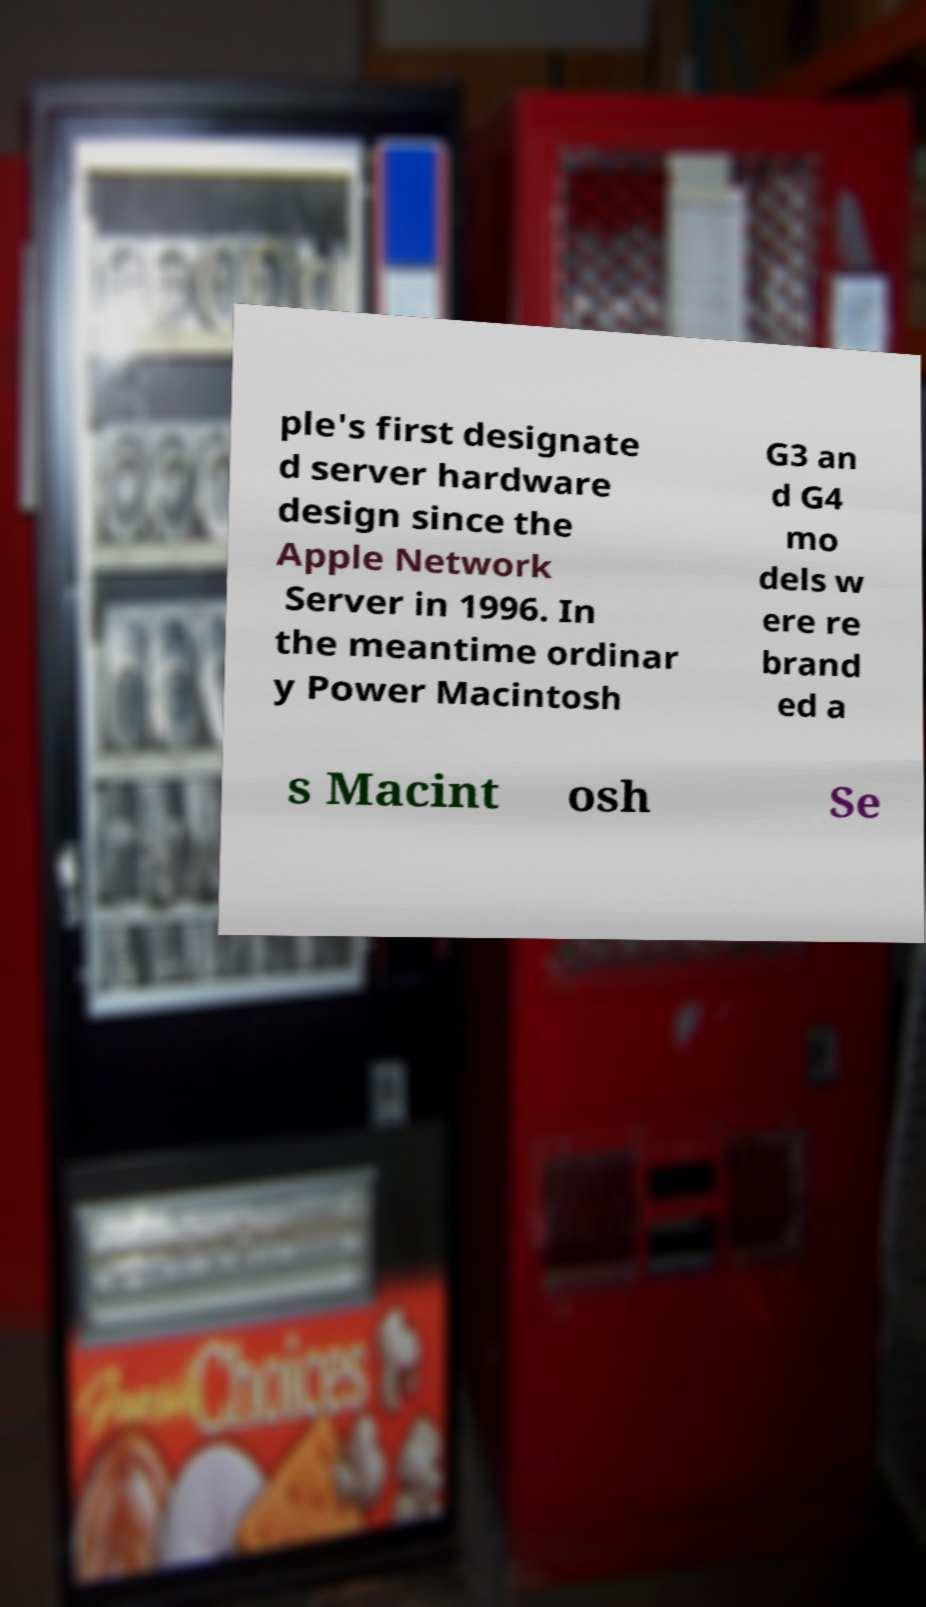Please read and relay the text visible in this image. What does it say? ple's first designate d server hardware design since the Apple Network Server in 1996. In the meantime ordinar y Power Macintosh G3 an d G4 mo dels w ere re brand ed a s Macint osh Se 